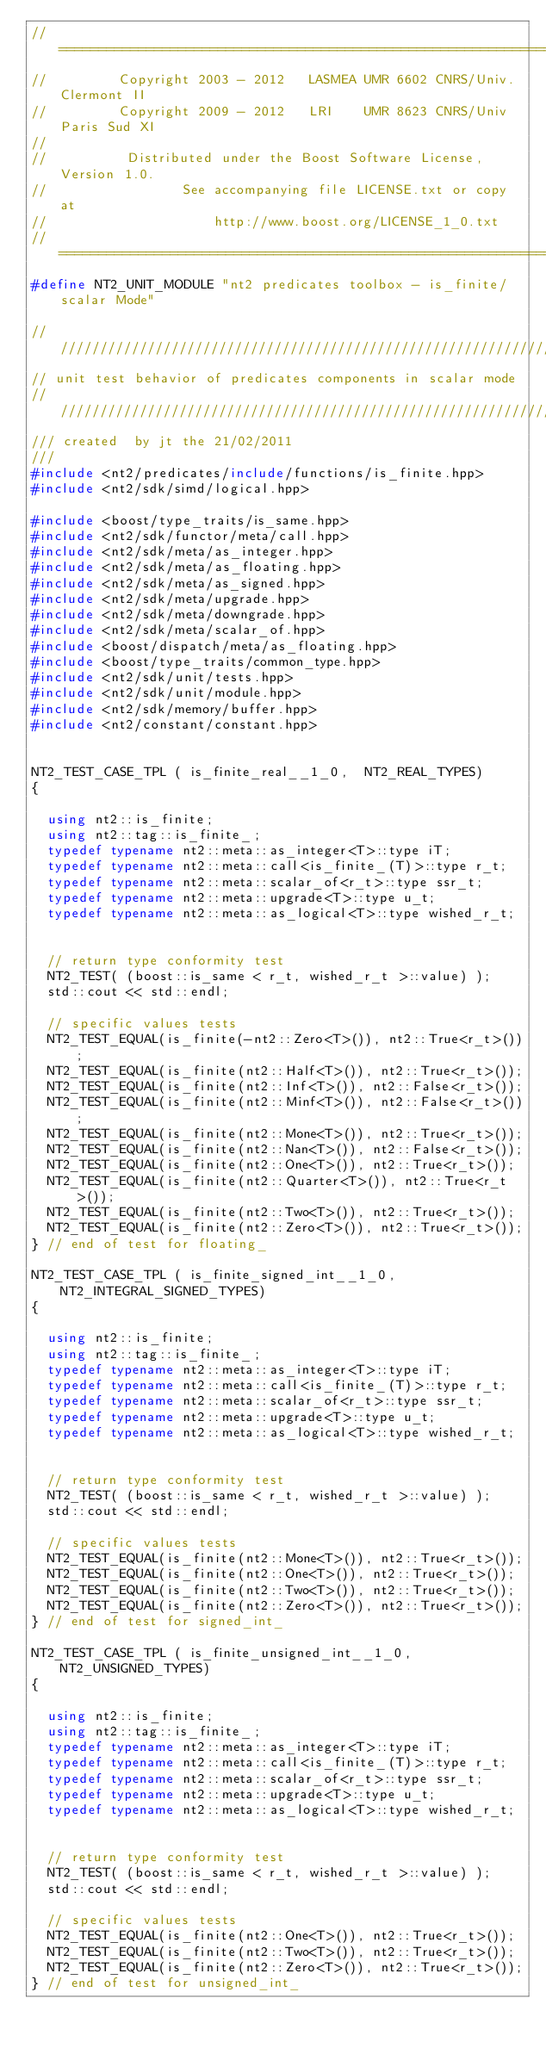Convert code to text. <code><loc_0><loc_0><loc_500><loc_500><_C++_>//==============================================================================
//         Copyright 2003 - 2012   LASMEA UMR 6602 CNRS/Univ. Clermont II
//         Copyright 2009 - 2012   LRI    UMR 8623 CNRS/Univ Paris Sud XI
//
//          Distributed under the Boost Software License, Version 1.0.
//                 See accompanying file LICENSE.txt or copy at
//                     http://www.boost.org/LICENSE_1_0.txt
//==============================================================================
#define NT2_UNIT_MODULE "nt2 predicates toolbox - is_finite/scalar Mode"

//////////////////////////////////////////////////////////////////////////////
// unit test behavior of predicates components in scalar mode
//////////////////////////////////////////////////////////////////////////////
/// created  by jt the 21/02/2011
///
#include <nt2/predicates/include/functions/is_finite.hpp>
#include <nt2/sdk/simd/logical.hpp>

#include <boost/type_traits/is_same.hpp>
#include <nt2/sdk/functor/meta/call.hpp>
#include <nt2/sdk/meta/as_integer.hpp>
#include <nt2/sdk/meta/as_floating.hpp>
#include <nt2/sdk/meta/as_signed.hpp>
#include <nt2/sdk/meta/upgrade.hpp>
#include <nt2/sdk/meta/downgrade.hpp>
#include <nt2/sdk/meta/scalar_of.hpp>
#include <boost/dispatch/meta/as_floating.hpp>
#include <boost/type_traits/common_type.hpp>
#include <nt2/sdk/unit/tests.hpp>
#include <nt2/sdk/unit/module.hpp>
#include <nt2/sdk/memory/buffer.hpp>
#include <nt2/constant/constant.hpp>


NT2_TEST_CASE_TPL ( is_finite_real__1_0,  NT2_REAL_TYPES)
{

  using nt2::is_finite;
  using nt2::tag::is_finite_;
  typedef typename nt2::meta::as_integer<T>::type iT;
  typedef typename nt2::meta::call<is_finite_(T)>::type r_t;
  typedef typename nt2::meta::scalar_of<r_t>::type ssr_t;
  typedef typename nt2::meta::upgrade<T>::type u_t;
  typedef typename nt2::meta::as_logical<T>::type wished_r_t;


  // return type conformity test
  NT2_TEST( (boost::is_same < r_t, wished_r_t >::value) );
  std::cout << std::endl;

  // specific values tests
  NT2_TEST_EQUAL(is_finite(-nt2::Zero<T>()), nt2::True<r_t>());
  NT2_TEST_EQUAL(is_finite(nt2::Half<T>()), nt2::True<r_t>());
  NT2_TEST_EQUAL(is_finite(nt2::Inf<T>()), nt2::False<r_t>());
  NT2_TEST_EQUAL(is_finite(nt2::Minf<T>()), nt2::False<r_t>());
  NT2_TEST_EQUAL(is_finite(nt2::Mone<T>()), nt2::True<r_t>());
  NT2_TEST_EQUAL(is_finite(nt2::Nan<T>()), nt2::False<r_t>());
  NT2_TEST_EQUAL(is_finite(nt2::One<T>()), nt2::True<r_t>());
  NT2_TEST_EQUAL(is_finite(nt2::Quarter<T>()), nt2::True<r_t>());
  NT2_TEST_EQUAL(is_finite(nt2::Two<T>()), nt2::True<r_t>());
  NT2_TEST_EQUAL(is_finite(nt2::Zero<T>()), nt2::True<r_t>());
} // end of test for floating_

NT2_TEST_CASE_TPL ( is_finite_signed_int__1_0,  NT2_INTEGRAL_SIGNED_TYPES)
{

  using nt2::is_finite;
  using nt2::tag::is_finite_;
  typedef typename nt2::meta::as_integer<T>::type iT;
  typedef typename nt2::meta::call<is_finite_(T)>::type r_t;
  typedef typename nt2::meta::scalar_of<r_t>::type ssr_t;
  typedef typename nt2::meta::upgrade<T>::type u_t;
  typedef typename nt2::meta::as_logical<T>::type wished_r_t;


  // return type conformity test
  NT2_TEST( (boost::is_same < r_t, wished_r_t >::value) );
  std::cout << std::endl;

  // specific values tests
  NT2_TEST_EQUAL(is_finite(nt2::Mone<T>()), nt2::True<r_t>());
  NT2_TEST_EQUAL(is_finite(nt2::One<T>()), nt2::True<r_t>());
  NT2_TEST_EQUAL(is_finite(nt2::Two<T>()), nt2::True<r_t>());
  NT2_TEST_EQUAL(is_finite(nt2::Zero<T>()), nt2::True<r_t>());
} // end of test for signed_int_

NT2_TEST_CASE_TPL ( is_finite_unsigned_int__1_0,  NT2_UNSIGNED_TYPES)
{

  using nt2::is_finite;
  using nt2::tag::is_finite_;
  typedef typename nt2::meta::as_integer<T>::type iT;
  typedef typename nt2::meta::call<is_finite_(T)>::type r_t;
  typedef typename nt2::meta::scalar_of<r_t>::type ssr_t;
  typedef typename nt2::meta::upgrade<T>::type u_t;
  typedef typename nt2::meta::as_logical<T>::type wished_r_t;


  // return type conformity test
  NT2_TEST( (boost::is_same < r_t, wished_r_t >::value) );
  std::cout << std::endl;

  // specific values tests
  NT2_TEST_EQUAL(is_finite(nt2::One<T>()), nt2::True<r_t>());
  NT2_TEST_EQUAL(is_finite(nt2::Two<T>()), nt2::True<r_t>());
  NT2_TEST_EQUAL(is_finite(nt2::Zero<T>()), nt2::True<r_t>());
} // end of test for unsigned_int_
</code> 